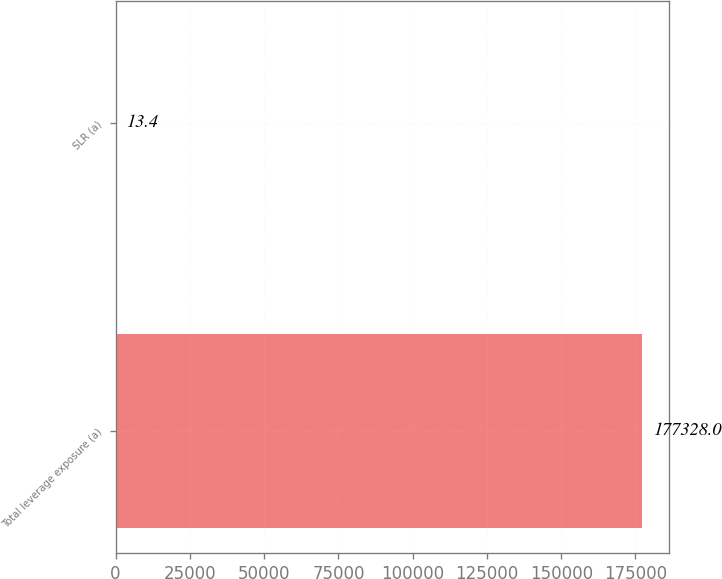Convert chart. <chart><loc_0><loc_0><loc_500><loc_500><bar_chart><fcel>Total leverage exposure (a)<fcel>SLR (a)<nl><fcel>177328<fcel>13.4<nl></chart> 